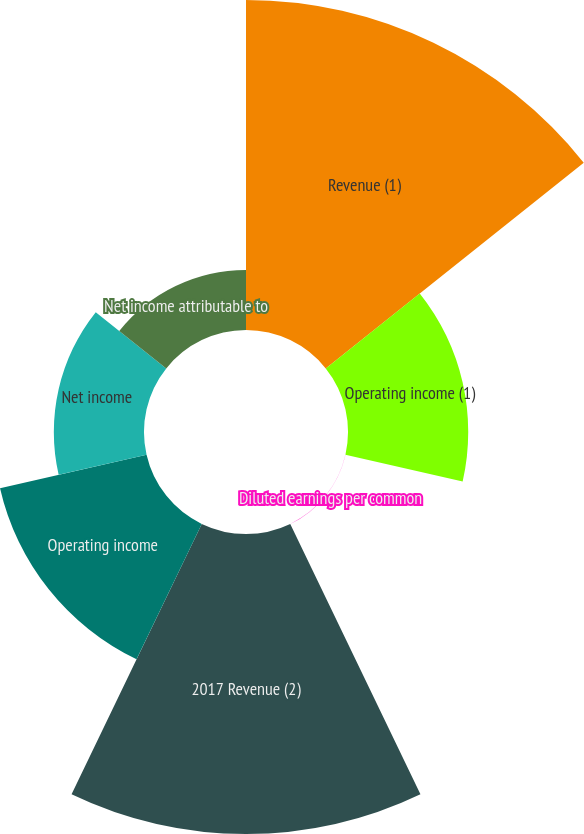Convert chart to OTSL. <chart><loc_0><loc_0><loc_500><loc_500><pie_chart><fcel>Revenue (1)<fcel>Operating income (1)<fcel>Diluted earnings per common<fcel>2017 Revenue (2)<fcel>Operating income<fcel>Net income<fcel>Net income attributable to<nl><fcel>31.4%<fcel>11.44%<fcel>0.01%<fcel>28.55%<fcel>14.3%<fcel>8.58%<fcel>5.72%<nl></chart> 